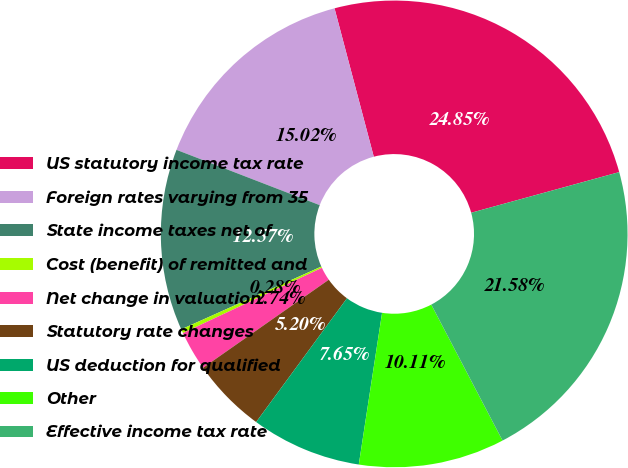Convert chart. <chart><loc_0><loc_0><loc_500><loc_500><pie_chart><fcel>US statutory income tax rate<fcel>Foreign rates varying from 35<fcel>State income taxes net of<fcel>Cost (benefit) of remitted and<fcel>Net change in valuation<fcel>Statutory rate changes<fcel>US deduction for qualified<fcel>Other<fcel>Effective income tax rate<nl><fcel>24.85%<fcel>15.02%<fcel>12.57%<fcel>0.28%<fcel>2.74%<fcel>5.2%<fcel>7.65%<fcel>10.11%<fcel>21.58%<nl></chart> 